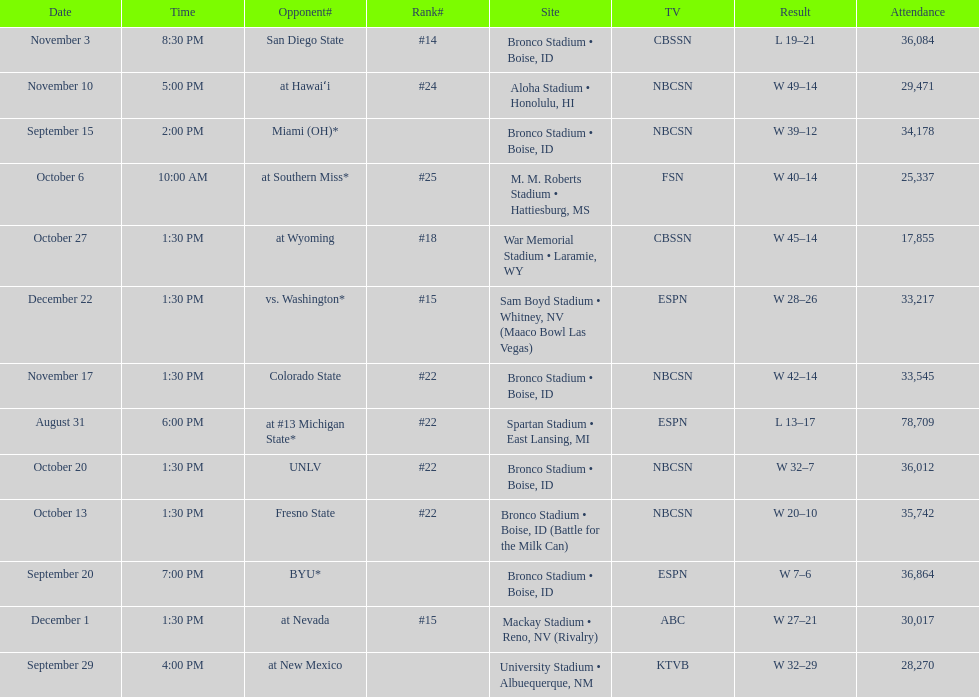Opponent broncos faced next after unlv Wyoming. I'm looking to parse the entire table for insights. Could you assist me with that? {'header': ['Date', 'Time', 'Opponent#', 'Rank#', 'Site', 'TV', 'Result', 'Attendance'], 'rows': [['November 3', '8:30 PM', 'San Diego State', '#14', 'Bronco Stadium • Boise, ID', 'CBSSN', 'L\xa019–21', '36,084'], ['November 10', '5:00 PM', 'at\xa0Hawaiʻi', '#24', 'Aloha Stadium • Honolulu, HI', 'NBCSN', 'W\xa049–14', '29,471'], ['September 15', '2:00 PM', 'Miami (OH)*', '', 'Bronco Stadium • Boise, ID', 'NBCSN', 'W\xa039–12', '34,178'], ['October 6', '10:00 AM', 'at\xa0Southern Miss*', '#25', 'M. M. Roberts Stadium • Hattiesburg, MS', 'FSN', 'W\xa040–14', '25,337'], ['October 27', '1:30 PM', 'at\xa0Wyoming', '#18', 'War Memorial Stadium • Laramie, WY', 'CBSSN', 'W\xa045–14', '17,855'], ['December 22', '1:30 PM', 'vs.\xa0Washington*', '#15', 'Sam Boyd Stadium • Whitney, NV (Maaco Bowl Las Vegas)', 'ESPN', 'W\xa028–26', '33,217'], ['November 17', '1:30 PM', 'Colorado State', '#22', 'Bronco Stadium • Boise, ID', 'NBCSN', 'W\xa042–14', '33,545'], ['August 31', '6:00 PM', 'at\xa0#13\xa0Michigan State*', '#22', 'Spartan Stadium • East Lansing, MI', 'ESPN', 'L\xa013–17', '78,709'], ['October 20', '1:30 PM', 'UNLV', '#22', 'Bronco Stadium • Boise, ID', 'NBCSN', 'W\xa032–7', '36,012'], ['October 13', '1:30 PM', 'Fresno State', '#22', 'Bronco Stadium • Boise, ID (Battle for the Milk Can)', 'NBCSN', 'W\xa020–10', '35,742'], ['September 20', '7:00 PM', 'BYU*', '', 'Bronco Stadium • Boise, ID', 'ESPN', 'W\xa07–6', '36,864'], ['December 1', '1:30 PM', 'at\xa0Nevada', '#15', 'Mackay Stadium • Reno, NV (Rivalry)', 'ABC', 'W\xa027–21', '30,017'], ['September 29', '4:00 PM', 'at\xa0New Mexico', '', 'University Stadium • Albuequerque, NM', 'KTVB', 'W\xa032–29', '28,270']]} 